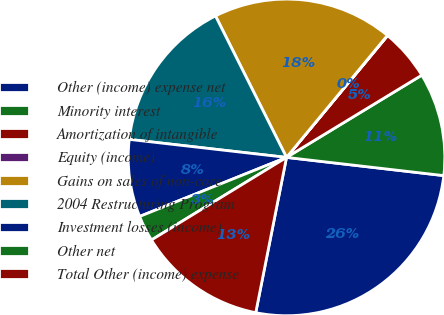<chart> <loc_0><loc_0><loc_500><loc_500><pie_chart><fcel>Other (income) expense net<fcel>Minority interest<fcel>Amortization of intangible<fcel>Equity (income)<fcel>Gains on sales of non-core<fcel>2004 Restructuring Program<fcel>Investment losses (income)<fcel>Other net<fcel>Total Other (income) expense<nl><fcel>26.28%<fcel>10.53%<fcel>5.28%<fcel>0.03%<fcel>18.4%<fcel>15.78%<fcel>7.9%<fcel>2.65%<fcel>13.15%<nl></chart> 